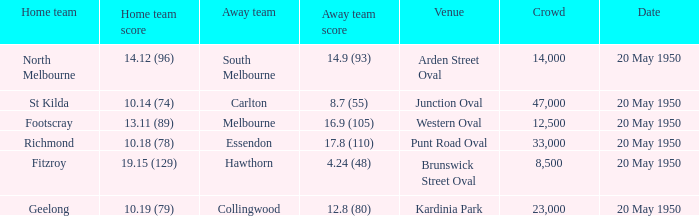Parse the table in full. {'header': ['Home team', 'Home team score', 'Away team', 'Away team score', 'Venue', 'Crowd', 'Date'], 'rows': [['North Melbourne', '14.12 (96)', 'South Melbourne', '14.9 (93)', 'Arden Street Oval', '14,000', '20 May 1950'], ['St Kilda', '10.14 (74)', 'Carlton', '8.7 (55)', 'Junction Oval', '47,000', '20 May 1950'], ['Footscray', '13.11 (89)', 'Melbourne', '16.9 (105)', 'Western Oval', '12,500', '20 May 1950'], ['Richmond', '10.18 (78)', 'Essendon', '17.8 (110)', 'Punt Road Oval', '33,000', '20 May 1950'], ['Fitzroy', '19.15 (129)', 'Hawthorn', '4.24 (48)', 'Brunswick Street Oval', '8,500', '20 May 1950'], ['Geelong', '10.19 (79)', 'Collingwood', '12.8 (80)', 'Kardinia Park', '23,000', '20 May 1950']]} What was the venue when the away team scored 14.9 (93)? Arden Street Oval. 